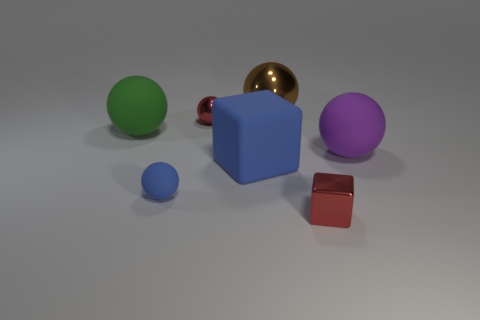What can you infer about the lighting in this scene? The lighting in this scene appears to be soft and diffused, coming from above. This can be inferred from the gentle shadows cast by the objects on the surface and the subtle highlights on the spheres and cubes that suggest a broad light source. 